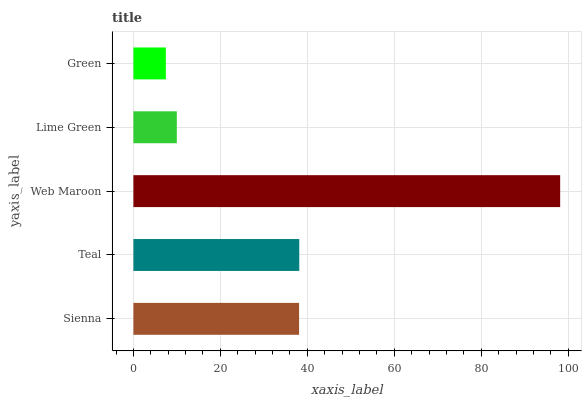Is Green the minimum?
Answer yes or no. Yes. Is Web Maroon the maximum?
Answer yes or no. Yes. Is Teal the minimum?
Answer yes or no. No. Is Teal the maximum?
Answer yes or no. No. Is Teal greater than Sienna?
Answer yes or no. Yes. Is Sienna less than Teal?
Answer yes or no. Yes. Is Sienna greater than Teal?
Answer yes or no. No. Is Teal less than Sienna?
Answer yes or no. No. Is Sienna the high median?
Answer yes or no. Yes. Is Sienna the low median?
Answer yes or no. Yes. Is Web Maroon the high median?
Answer yes or no. No. Is Lime Green the low median?
Answer yes or no. No. 